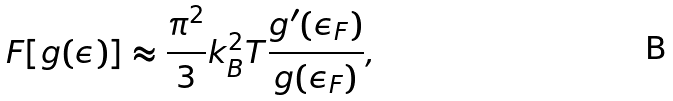Convert formula to latex. <formula><loc_0><loc_0><loc_500><loc_500>F [ g ( \epsilon ) ] \approx \frac { \pi ^ { 2 } } { 3 } k _ { B } ^ { 2 } T \frac { g ^ { \prime } ( \epsilon _ { F } ) } { g ( \epsilon _ { F } ) } ,</formula> 